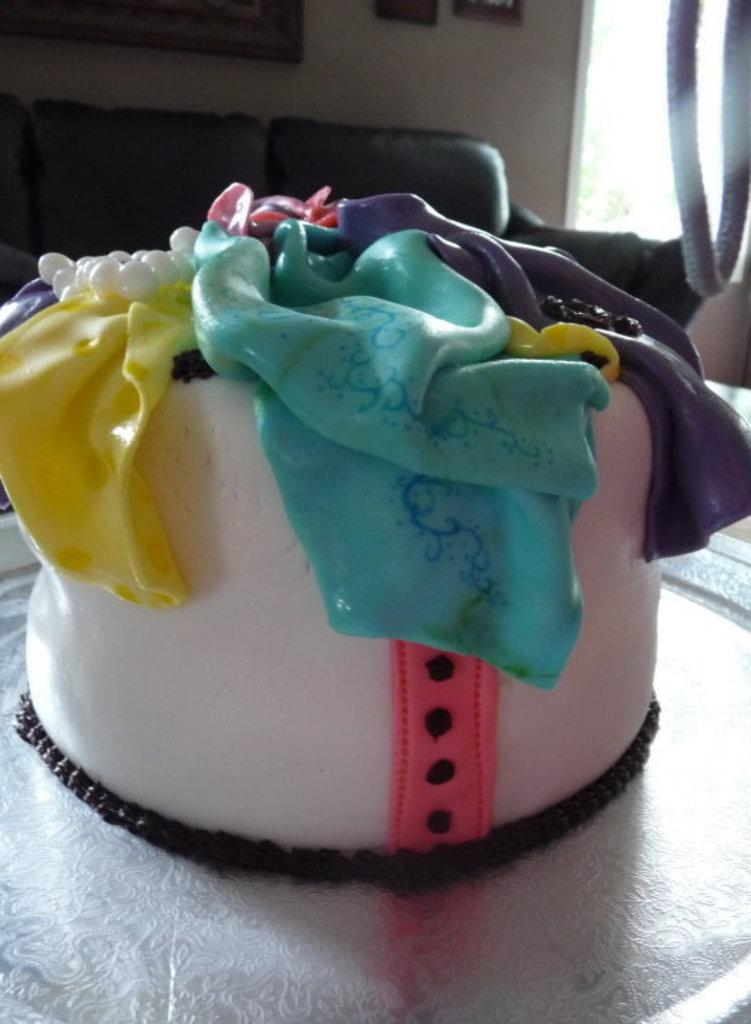What is the main food item visible in the image? There is a cake on a plate in the image. What type of furniture can be seen in the background of the image? There is a couch in the background of the image. What is hanging on the wall in the background of the image? There are frames on the wall in the background of the image. What allows natural light to enter the room in the image? There is a window in the background of the image. What else can be seen in the background of the image? There are objects visible in the background of the image. What relation does the person in the image have to the person celebrating their birthday? There is no person visible in the image, so it is impossible to determine any relationships. 